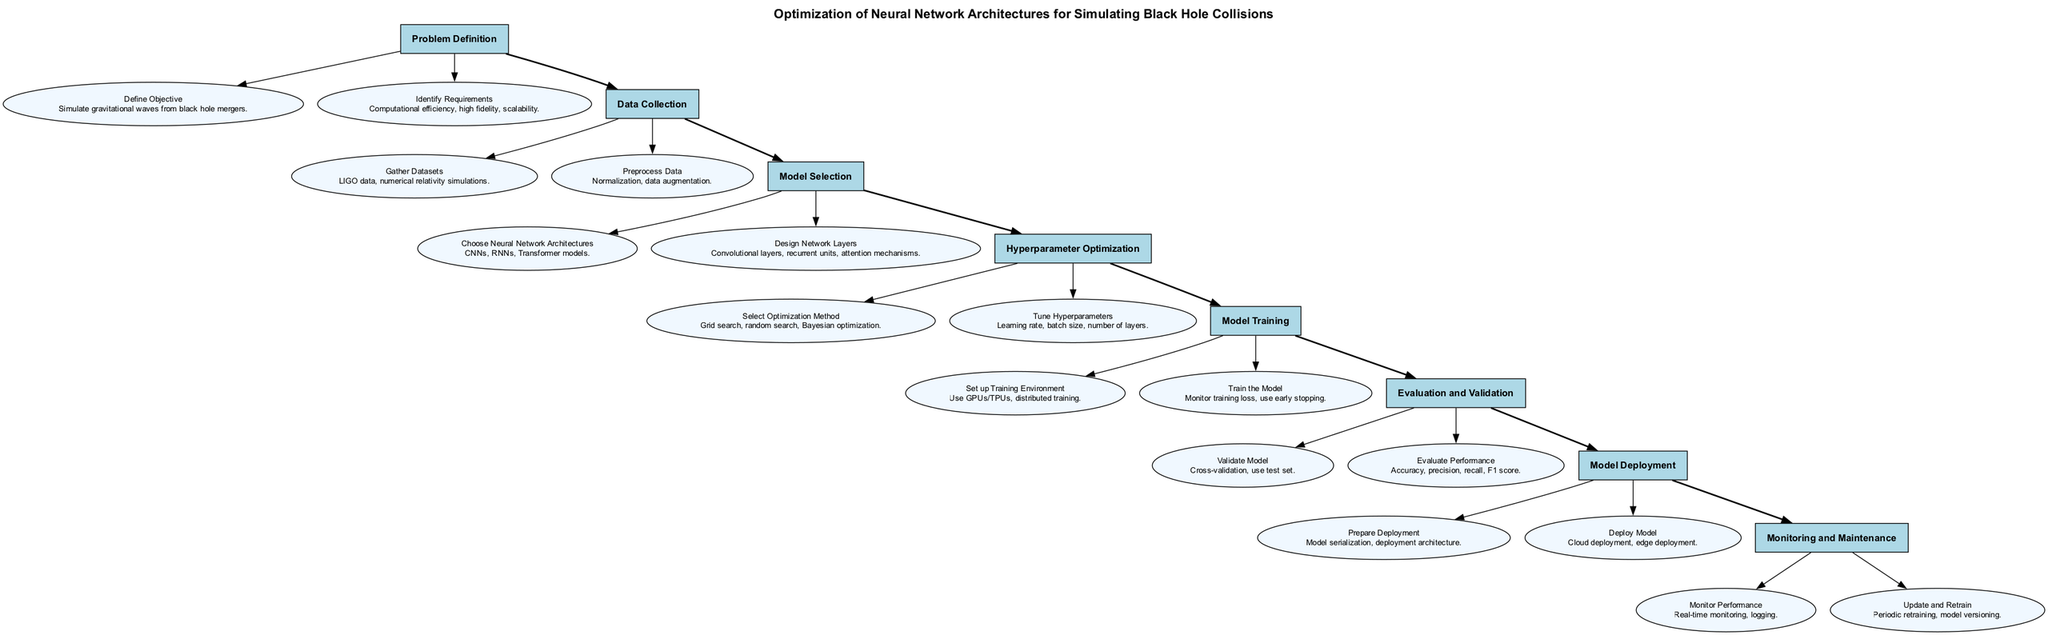What is the title of the clinical pathway? The title node in the diagram states "Optimization of Neural Network Architectures for Simulating Black Hole Collisions." This is directly retrieved from the main title representation in the diagram.
Answer: Optimization of Neural Network Architectures for Simulating Black Hole Collisions How many main steps are there in the pathway? The main steps of the pathway are listed sequentially; counting them gives us a total of eight distinct steps presented in the diagram.
Answer: 8 Which step follows "Hyperparameter Optimization"? The diagram shows a directed flow that indicates the sequence of steps; after "Hyperparameter Optimization," the following step is labeled "Model Training."
Answer: Model Training What task is included in the "Model Selection" step? In the "Model Selection" step, there are two tasks listed. The first task is to "Choose Neural Network Architectures." This is identified from the task nodes connected to this particular step.
Answer: Choose Neural Network Architectures What are the evaluation metrics mentioned in the "Evaluation and Validation" step? The "Evaluation and Validation" step outlines various performance metrics, which include "Accuracy, precision, recall, F1 score." This is derived from the task details within that step.
Answer: Accuracy, precision, recall, F1 score Which step has the task "Update and Retrain"? By tracing the diagram, "Update and Retrain" is found as a task belonging to the last step in the pathway, which is "Monitoring and Maintenance."
Answer: Monitoring and Maintenance What type of neural network architectures are mentioned in the "Model Selection" step? The tasks listed in the "Model Selection" step specify architectures such as "CNNs, RNNs, Transformer models." Retrieving this information involves looking at the tasks connected to this particular step.
Answer: CNNs, RNNs, Transformer models What is the objective defined in the "Problem Definition" step? The first task in the "Problem Definition" states the objective as "Simulate gravitational waves from black hole mergers." This is taken directly from the detailed description of the task in the diagram.
Answer: Simulate gravitational waves from black hole mergers How is the training environment set up according to the diagram? The "Model Training" step specifies the task to "Set up Training Environment," which includes using GPUs/TPUs and distributed training; this information is explicitly stated in the task details.
Answer: Use GPUs/TPUs, distributed training 